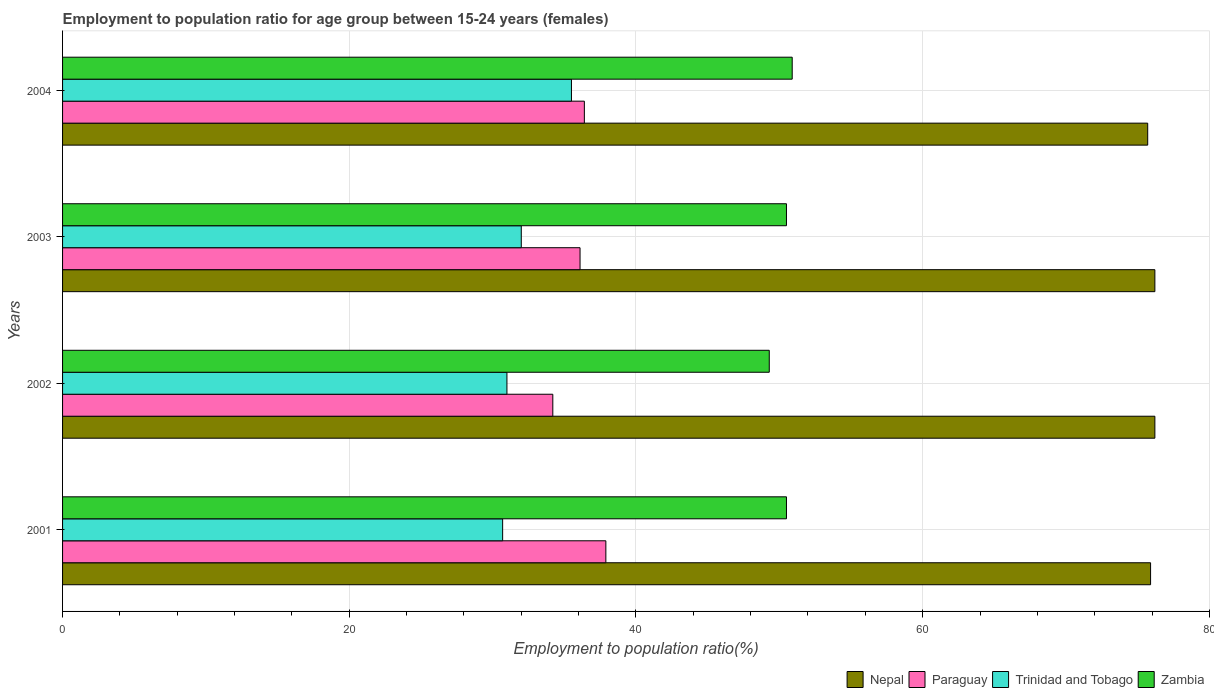How many groups of bars are there?
Provide a succinct answer. 4. Are the number of bars per tick equal to the number of legend labels?
Keep it short and to the point. Yes. Are the number of bars on each tick of the Y-axis equal?
Give a very brief answer. Yes. How many bars are there on the 2nd tick from the top?
Offer a very short reply. 4. What is the label of the 4th group of bars from the top?
Offer a very short reply. 2001. In how many cases, is the number of bars for a given year not equal to the number of legend labels?
Keep it short and to the point. 0. What is the employment to population ratio in Paraguay in 2003?
Give a very brief answer. 36.1. Across all years, what is the maximum employment to population ratio in Trinidad and Tobago?
Provide a succinct answer. 35.5. Across all years, what is the minimum employment to population ratio in Trinidad and Tobago?
Provide a succinct answer. 30.7. In which year was the employment to population ratio in Nepal maximum?
Make the answer very short. 2002. In which year was the employment to population ratio in Nepal minimum?
Ensure brevity in your answer.  2004. What is the total employment to population ratio in Nepal in the graph?
Keep it short and to the point. 304. What is the difference between the employment to population ratio in Trinidad and Tobago in 2001 and that in 2004?
Ensure brevity in your answer.  -4.8. What is the difference between the employment to population ratio in Paraguay in 2004 and the employment to population ratio in Nepal in 2001?
Offer a terse response. -39.5. What is the average employment to population ratio in Paraguay per year?
Keep it short and to the point. 36.15. In the year 2004, what is the difference between the employment to population ratio in Zambia and employment to population ratio in Nepal?
Ensure brevity in your answer.  -24.8. What is the ratio of the employment to population ratio in Zambia in 2002 to that in 2003?
Make the answer very short. 0.98. Is the employment to population ratio in Trinidad and Tobago in 2003 less than that in 2004?
Your answer should be very brief. Yes. Is the difference between the employment to population ratio in Zambia in 2002 and 2003 greater than the difference between the employment to population ratio in Nepal in 2002 and 2003?
Make the answer very short. No. What is the difference between the highest and the second highest employment to population ratio in Zambia?
Provide a short and direct response. 0.4. What does the 1st bar from the top in 2001 represents?
Offer a very short reply. Zambia. What does the 4th bar from the bottom in 2004 represents?
Give a very brief answer. Zambia. Are all the bars in the graph horizontal?
Your answer should be very brief. Yes. Are the values on the major ticks of X-axis written in scientific E-notation?
Ensure brevity in your answer.  No. Does the graph contain grids?
Keep it short and to the point. Yes. What is the title of the graph?
Offer a terse response. Employment to population ratio for age group between 15-24 years (females). What is the label or title of the Y-axis?
Provide a short and direct response. Years. What is the Employment to population ratio(%) in Nepal in 2001?
Give a very brief answer. 75.9. What is the Employment to population ratio(%) of Paraguay in 2001?
Make the answer very short. 37.9. What is the Employment to population ratio(%) in Trinidad and Tobago in 2001?
Provide a short and direct response. 30.7. What is the Employment to population ratio(%) of Zambia in 2001?
Provide a succinct answer. 50.5. What is the Employment to population ratio(%) of Nepal in 2002?
Offer a very short reply. 76.2. What is the Employment to population ratio(%) in Paraguay in 2002?
Provide a short and direct response. 34.2. What is the Employment to population ratio(%) in Trinidad and Tobago in 2002?
Your answer should be compact. 31. What is the Employment to population ratio(%) of Zambia in 2002?
Make the answer very short. 49.3. What is the Employment to population ratio(%) in Nepal in 2003?
Make the answer very short. 76.2. What is the Employment to population ratio(%) of Paraguay in 2003?
Your answer should be very brief. 36.1. What is the Employment to population ratio(%) in Trinidad and Tobago in 2003?
Offer a very short reply. 32. What is the Employment to population ratio(%) in Zambia in 2003?
Give a very brief answer. 50.5. What is the Employment to population ratio(%) in Nepal in 2004?
Provide a short and direct response. 75.7. What is the Employment to population ratio(%) of Paraguay in 2004?
Offer a very short reply. 36.4. What is the Employment to population ratio(%) in Trinidad and Tobago in 2004?
Offer a terse response. 35.5. What is the Employment to population ratio(%) in Zambia in 2004?
Your response must be concise. 50.9. Across all years, what is the maximum Employment to population ratio(%) of Nepal?
Make the answer very short. 76.2. Across all years, what is the maximum Employment to population ratio(%) of Paraguay?
Keep it short and to the point. 37.9. Across all years, what is the maximum Employment to population ratio(%) of Trinidad and Tobago?
Make the answer very short. 35.5. Across all years, what is the maximum Employment to population ratio(%) of Zambia?
Your answer should be compact. 50.9. Across all years, what is the minimum Employment to population ratio(%) in Nepal?
Your response must be concise. 75.7. Across all years, what is the minimum Employment to population ratio(%) of Paraguay?
Ensure brevity in your answer.  34.2. Across all years, what is the minimum Employment to population ratio(%) of Trinidad and Tobago?
Your response must be concise. 30.7. Across all years, what is the minimum Employment to population ratio(%) in Zambia?
Your answer should be compact. 49.3. What is the total Employment to population ratio(%) in Nepal in the graph?
Give a very brief answer. 304. What is the total Employment to population ratio(%) of Paraguay in the graph?
Offer a terse response. 144.6. What is the total Employment to population ratio(%) of Trinidad and Tobago in the graph?
Keep it short and to the point. 129.2. What is the total Employment to population ratio(%) in Zambia in the graph?
Offer a very short reply. 201.2. What is the difference between the Employment to population ratio(%) of Nepal in 2001 and that in 2002?
Give a very brief answer. -0.3. What is the difference between the Employment to population ratio(%) in Paraguay in 2001 and that in 2002?
Offer a very short reply. 3.7. What is the difference between the Employment to population ratio(%) in Nepal in 2001 and that in 2003?
Keep it short and to the point. -0.3. What is the difference between the Employment to population ratio(%) of Trinidad and Tobago in 2001 and that in 2003?
Provide a short and direct response. -1.3. What is the difference between the Employment to population ratio(%) in Zambia in 2001 and that in 2004?
Offer a very short reply. -0.4. What is the difference between the Employment to population ratio(%) of Nepal in 2002 and that in 2003?
Your response must be concise. 0. What is the difference between the Employment to population ratio(%) of Trinidad and Tobago in 2002 and that in 2003?
Provide a short and direct response. -1. What is the difference between the Employment to population ratio(%) in Zambia in 2002 and that in 2003?
Your answer should be compact. -1.2. What is the difference between the Employment to population ratio(%) of Zambia in 2002 and that in 2004?
Your response must be concise. -1.6. What is the difference between the Employment to population ratio(%) of Paraguay in 2003 and that in 2004?
Make the answer very short. -0.3. What is the difference between the Employment to population ratio(%) of Trinidad and Tobago in 2003 and that in 2004?
Make the answer very short. -3.5. What is the difference between the Employment to population ratio(%) of Nepal in 2001 and the Employment to population ratio(%) of Paraguay in 2002?
Offer a terse response. 41.7. What is the difference between the Employment to population ratio(%) of Nepal in 2001 and the Employment to population ratio(%) of Trinidad and Tobago in 2002?
Your answer should be compact. 44.9. What is the difference between the Employment to population ratio(%) of Nepal in 2001 and the Employment to population ratio(%) of Zambia in 2002?
Provide a short and direct response. 26.6. What is the difference between the Employment to population ratio(%) of Paraguay in 2001 and the Employment to population ratio(%) of Trinidad and Tobago in 2002?
Offer a very short reply. 6.9. What is the difference between the Employment to population ratio(%) of Trinidad and Tobago in 2001 and the Employment to population ratio(%) of Zambia in 2002?
Keep it short and to the point. -18.6. What is the difference between the Employment to population ratio(%) in Nepal in 2001 and the Employment to population ratio(%) in Paraguay in 2003?
Offer a terse response. 39.8. What is the difference between the Employment to population ratio(%) in Nepal in 2001 and the Employment to population ratio(%) in Trinidad and Tobago in 2003?
Give a very brief answer. 43.9. What is the difference between the Employment to population ratio(%) in Nepal in 2001 and the Employment to population ratio(%) in Zambia in 2003?
Your response must be concise. 25.4. What is the difference between the Employment to population ratio(%) in Paraguay in 2001 and the Employment to population ratio(%) in Trinidad and Tobago in 2003?
Offer a terse response. 5.9. What is the difference between the Employment to population ratio(%) of Paraguay in 2001 and the Employment to population ratio(%) of Zambia in 2003?
Keep it short and to the point. -12.6. What is the difference between the Employment to population ratio(%) of Trinidad and Tobago in 2001 and the Employment to population ratio(%) of Zambia in 2003?
Your answer should be very brief. -19.8. What is the difference between the Employment to population ratio(%) in Nepal in 2001 and the Employment to population ratio(%) in Paraguay in 2004?
Offer a terse response. 39.5. What is the difference between the Employment to population ratio(%) of Nepal in 2001 and the Employment to population ratio(%) of Trinidad and Tobago in 2004?
Ensure brevity in your answer.  40.4. What is the difference between the Employment to population ratio(%) in Trinidad and Tobago in 2001 and the Employment to population ratio(%) in Zambia in 2004?
Offer a terse response. -20.2. What is the difference between the Employment to population ratio(%) of Nepal in 2002 and the Employment to population ratio(%) of Paraguay in 2003?
Make the answer very short. 40.1. What is the difference between the Employment to population ratio(%) in Nepal in 2002 and the Employment to population ratio(%) in Trinidad and Tobago in 2003?
Your answer should be very brief. 44.2. What is the difference between the Employment to population ratio(%) of Nepal in 2002 and the Employment to population ratio(%) of Zambia in 2003?
Your answer should be very brief. 25.7. What is the difference between the Employment to population ratio(%) of Paraguay in 2002 and the Employment to population ratio(%) of Zambia in 2003?
Offer a very short reply. -16.3. What is the difference between the Employment to population ratio(%) in Trinidad and Tobago in 2002 and the Employment to population ratio(%) in Zambia in 2003?
Keep it short and to the point. -19.5. What is the difference between the Employment to population ratio(%) of Nepal in 2002 and the Employment to population ratio(%) of Paraguay in 2004?
Your answer should be very brief. 39.8. What is the difference between the Employment to population ratio(%) of Nepal in 2002 and the Employment to population ratio(%) of Trinidad and Tobago in 2004?
Give a very brief answer. 40.7. What is the difference between the Employment to population ratio(%) in Nepal in 2002 and the Employment to population ratio(%) in Zambia in 2004?
Your answer should be compact. 25.3. What is the difference between the Employment to population ratio(%) of Paraguay in 2002 and the Employment to population ratio(%) of Trinidad and Tobago in 2004?
Your answer should be very brief. -1.3. What is the difference between the Employment to population ratio(%) in Paraguay in 2002 and the Employment to population ratio(%) in Zambia in 2004?
Your answer should be compact. -16.7. What is the difference between the Employment to population ratio(%) of Trinidad and Tobago in 2002 and the Employment to population ratio(%) of Zambia in 2004?
Ensure brevity in your answer.  -19.9. What is the difference between the Employment to population ratio(%) in Nepal in 2003 and the Employment to population ratio(%) in Paraguay in 2004?
Your answer should be compact. 39.8. What is the difference between the Employment to population ratio(%) in Nepal in 2003 and the Employment to population ratio(%) in Trinidad and Tobago in 2004?
Offer a very short reply. 40.7. What is the difference between the Employment to population ratio(%) of Nepal in 2003 and the Employment to population ratio(%) of Zambia in 2004?
Your answer should be very brief. 25.3. What is the difference between the Employment to population ratio(%) of Paraguay in 2003 and the Employment to population ratio(%) of Trinidad and Tobago in 2004?
Provide a succinct answer. 0.6. What is the difference between the Employment to population ratio(%) in Paraguay in 2003 and the Employment to population ratio(%) in Zambia in 2004?
Keep it short and to the point. -14.8. What is the difference between the Employment to population ratio(%) of Trinidad and Tobago in 2003 and the Employment to population ratio(%) of Zambia in 2004?
Make the answer very short. -18.9. What is the average Employment to population ratio(%) of Paraguay per year?
Give a very brief answer. 36.15. What is the average Employment to population ratio(%) of Trinidad and Tobago per year?
Give a very brief answer. 32.3. What is the average Employment to population ratio(%) in Zambia per year?
Provide a short and direct response. 50.3. In the year 2001, what is the difference between the Employment to population ratio(%) in Nepal and Employment to population ratio(%) in Paraguay?
Offer a very short reply. 38. In the year 2001, what is the difference between the Employment to population ratio(%) in Nepal and Employment to population ratio(%) in Trinidad and Tobago?
Keep it short and to the point. 45.2. In the year 2001, what is the difference between the Employment to population ratio(%) in Nepal and Employment to population ratio(%) in Zambia?
Offer a terse response. 25.4. In the year 2001, what is the difference between the Employment to population ratio(%) in Paraguay and Employment to population ratio(%) in Trinidad and Tobago?
Your answer should be very brief. 7.2. In the year 2001, what is the difference between the Employment to population ratio(%) in Trinidad and Tobago and Employment to population ratio(%) in Zambia?
Give a very brief answer. -19.8. In the year 2002, what is the difference between the Employment to population ratio(%) in Nepal and Employment to population ratio(%) in Paraguay?
Give a very brief answer. 42. In the year 2002, what is the difference between the Employment to population ratio(%) in Nepal and Employment to population ratio(%) in Trinidad and Tobago?
Provide a succinct answer. 45.2. In the year 2002, what is the difference between the Employment to population ratio(%) of Nepal and Employment to population ratio(%) of Zambia?
Your response must be concise. 26.9. In the year 2002, what is the difference between the Employment to population ratio(%) of Paraguay and Employment to population ratio(%) of Trinidad and Tobago?
Your answer should be very brief. 3.2. In the year 2002, what is the difference between the Employment to population ratio(%) of Paraguay and Employment to population ratio(%) of Zambia?
Keep it short and to the point. -15.1. In the year 2002, what is the difference between the Employment to population ratio(%) of Trinidad and Tobago and Employment to population ratio(%) of Zambia?
Provide a succinct answer. -18.3. In the year 2003, what is the difference between the Employment to population ratio(%) of Nepal and Employment to population ratio(%) of Paraguay?
Give a very brief answer. 40.1. In the year 2003, what is the difference between the Employment to population ratio(%) of Nepal and Employment to population ratio(%) of Trinidad and Tobago?
Provide a succinct answer. 44.2. In the year 2003, what is the difference between the Employment to population ratio(%) of Nepal and Employment to population ratio(%) of Zambia?
Offer a terse response. 25.7. In the year 2003, what is the difference between the Employment to population ratio(%) in Paraguay and Employment to population ratio(%) in Zambia?
Your answer should be very brief. -14.4. In the year 2003, what is the difference between the Employment to population ratio(%) in Trinidad and Tobago and Employment to population ratio(%) in Zambia?
Give a very brief answer. -18.5. In the year 2004, what is the difference between the Employment to population ratio(%) of Nepal and Employment to population ratio(%) of Paraguay?
Offer a terse response. 39.3. In the year 2004, what is the difference between the Employment to population ratio(%) in Nepal and Employment to population ratio(%) in Trinidad and Tobago?
Give a very brief answer. 40.2. In the year 2004, what is the difference between the Employment to population ratio(%) of Nepal and Employment to population ratio(%) of Zambia?
Make the answer very short. 24.8. In the year 2004, what is the difference between the Employment to population ratio(%) of Paraguay and Employment to population ratio(%) of Trinidad and Tobago?
Offer a very short reply. 0.9. In the year 2004, what is the difference between the Employment to population ratio(%) of Trinidad and Tobago and Employment to population ratio(%) of Zambia?
Give a very brief answer. -15.4. What is the ratio of the Employment to population ratio(%) of Nepal in 2001 to that in 2002?
Keep it short and to the point. 1. What is the ratio of the Employment to population ratio(%) in Paraguay in 2001 to that in 2002?
Keep it short and to the point. 1.11. What is the ratio of the Employment to population ratio(%) in Trinidad and Tobago in 2001 to that in 2002?
Provide a succinct answer. 0.99. What is the ratio of the Employment to population ratio(%) in Zambia in 2001 to that in 2002?
Give a very brief answer. 1.02. What is the ratio of the Employment to population ratio(%) in Paraguay in 2001 to that in 2003?
Your response must be concise. 1.05. What is the ratio of the Employment to population ratio(%) in Trinidad and Tobago in 2001 to that in 2003?
Make the answer very short. 0.96. What is the ratio of the Employment to population ratio(%) in Nepal in 2001 to that in 2004?
Your answer should be compact. 1. What is the ratio of the Employment to population ratio(%) of Paraguay in 2001 to that in 2004?
Your answer should be very brief. 1.04. What is the ratio of the Employment to population ratio(%) of Trinidad and Tobago in 2001 to that in 2004?
Your response must be concise. 0.86. What is the ratio of the Employment to population ratio(%) in Trinidad and Tobago in 2002 to that in 2003?
Provide a short and direct response. 0.97. What is the ratio of the Employment to population ratio(%) in Zambia in 2002 to that in 2003?
Give a very brief answer. 0.98. What is the ratio of the Employment to population ratio(%) of Nepal in 2002 to that in 2004?
Give a very brief answer. 1.01. What is the ratio of the Employment to population ratio(%) in Paraguay in 2002 to that in 2004?
Provide a short and direct response. 0.94. What is the ratio of the Employment to population ratio(%) of Trinidad and Tobago in 2002 to that in 2004?
Your answer should be very brief. 0.87. What is the ratio of the Employment to population ratio(%) in Zambia in 2002 to that in 2004?
Offer a very short reply. 0.97. What is the ratio of the Employment to population ratio(%) in Nepal in 2003 to that in 2004?
Ensure brevity in your answer.  1.01. What is the ratio of the Employment to population ratio(%) in Trinidad and Tobago in 2003 to that in 2004?
Provide a succinct answer. 0.9. What is the ratio of the Employment to population ratio(%) of Zambia in 2003 to that in 2004?
Offer a terse response. 0.99. What is the difference between the highest and the second highest Employment to population ratio(%) of Trinidad and Tobago?
Give a very brief answer. 3.5. 